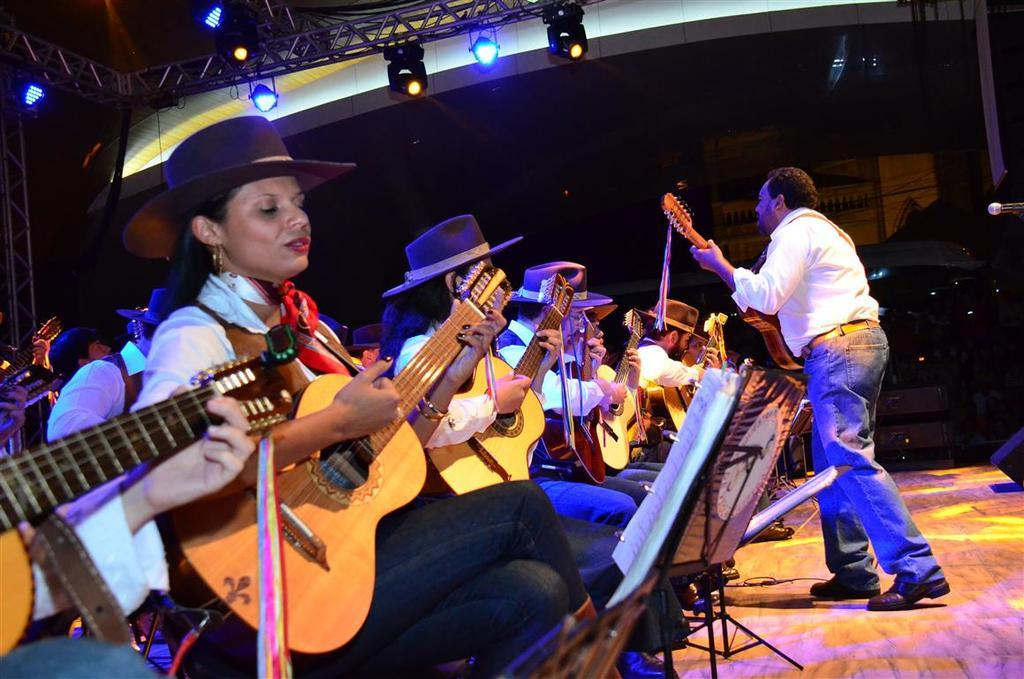What are the people in the image doing? The people in the image are sitting on chairs and playing guitars. Is there anyone standing in the image? Yes, there is a person standing and playing a guitar. What can be seen in the background of the image? There are poles and lights in the background of the image. What type of mist is present in the image? There is no mist present in the image. What government policy is being discussed in the image? The image does not depict any discussion of government policies. 